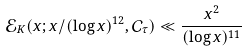<formula> <loc_0><loc_0><loc_500><loc_500>\mathcal { E } _ { K } ( x ; x / ( \log x ) ^ { 1 2 } , \mathcal { C } _ { \tau } ) \ll \frac { x ^ { 2 } } { ( \log x ) ^ { 1 1 } }</formula> 